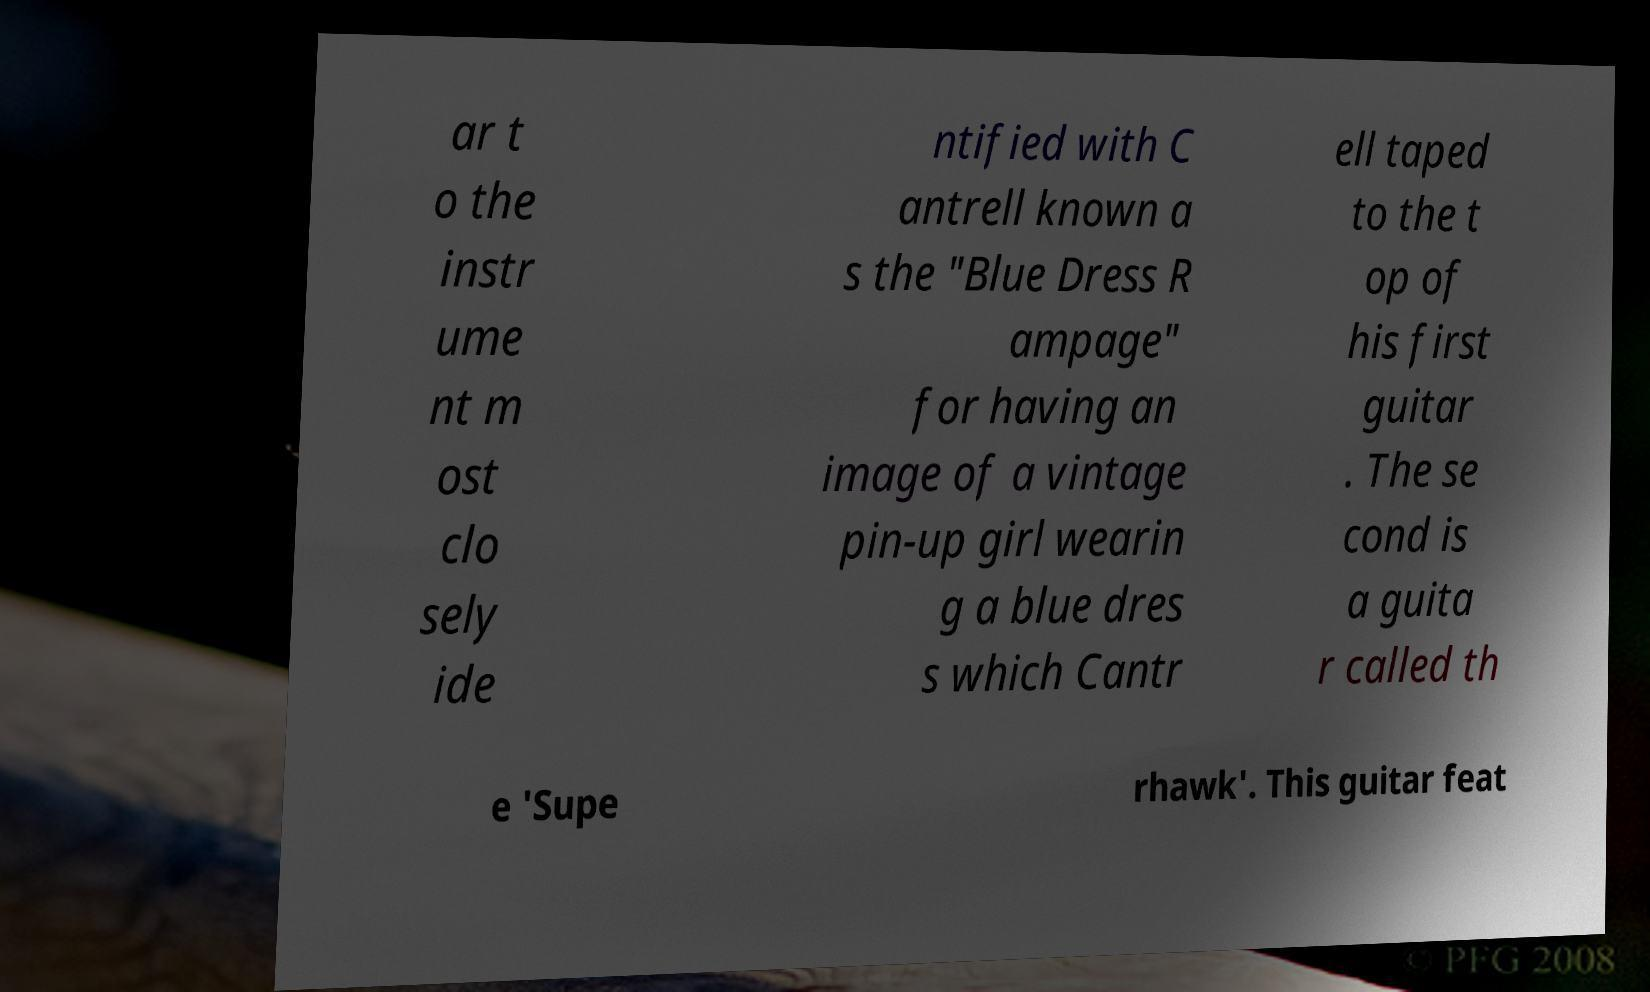Please read and relay the text visible in this image. What does it say? ar t o the instr ume nt m ost clo sely ide ntified with C antrell known a s the "Blue Dress R ampage" for having an image of a vintage pin-up girl wearin g a blue dres s which Cantr ell taped to the t op of his first guitar . The se cond is a guita r called th e 'Supe rhawk'. This guitar feat 